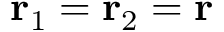Convert formula to latex. <formula><loc_0><loc_0><loc_500><loc_500>{ r } _ { 1 } = { r } _ { 2 } = { r }</formula> 